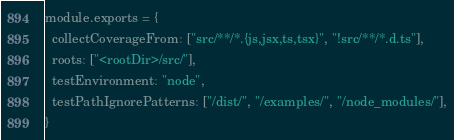Convert code to text. <code><loc_0><loc_0><loc_500><loc_500><_JavaScript_>module.exports = {
  collectCoverageFrom: ["src/**/*.{js,jsx,ts,tsx}", "!src/**/*.d.ts"],
  roots: ["<rootDir>/src/"],
  testEnvironment: "node",
  testPathIgnorePatterns: ["/dist/", "/examples/", "/node_modules/"],
}
</code> 